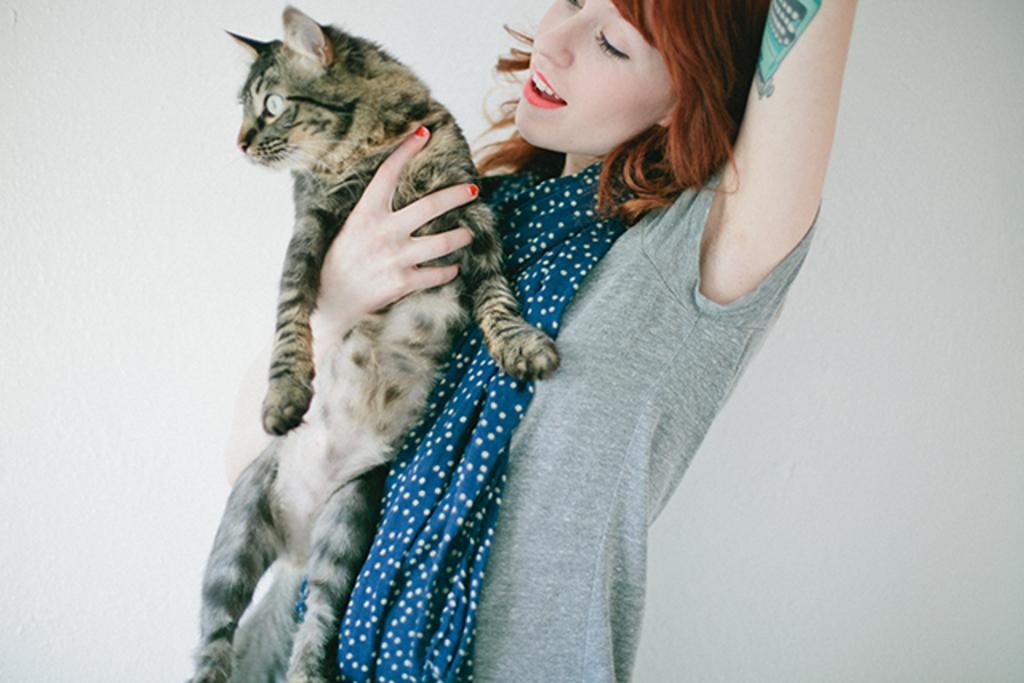Please provide a concise description of this image. This picture shows a woman wearing a t shirt and a scarf, holding a cat in her hand. In the background there is a wall. 